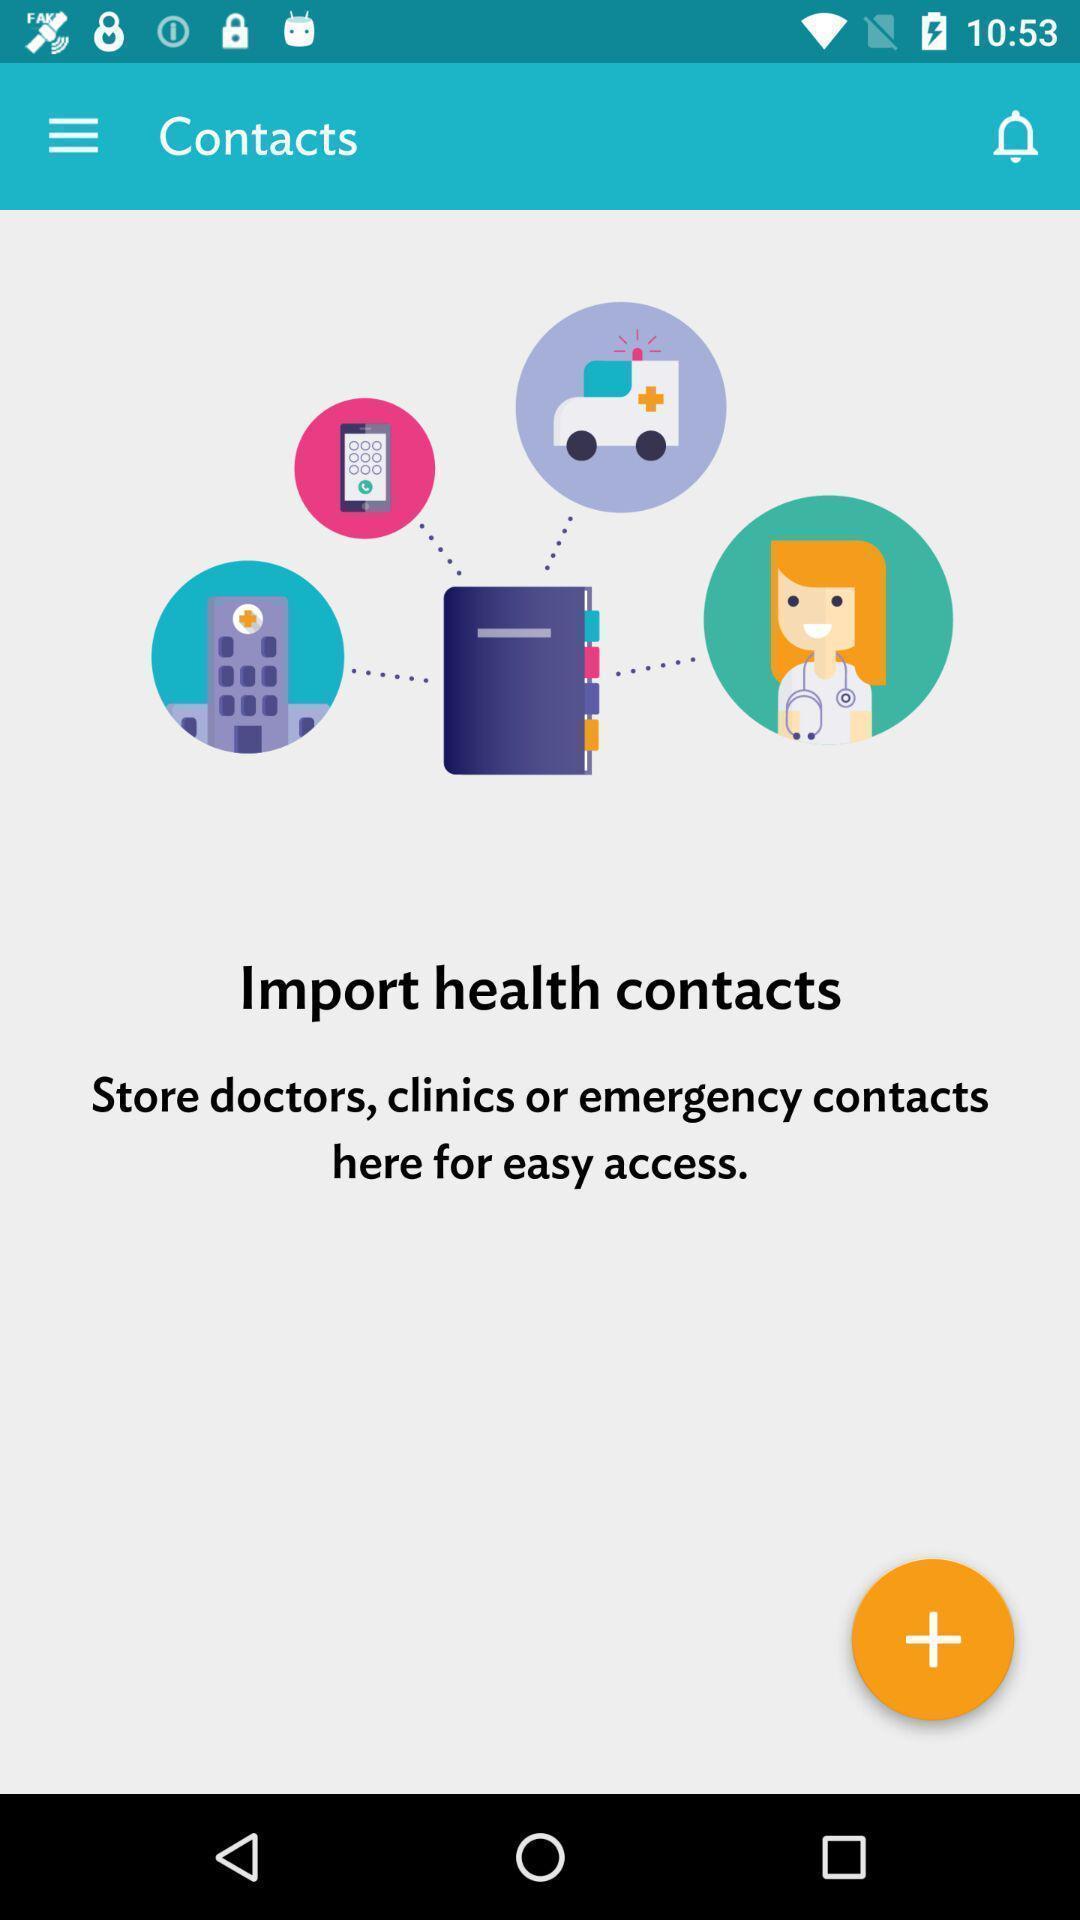Explain what's happening in this screen capture. Page showing option to add contacts. 